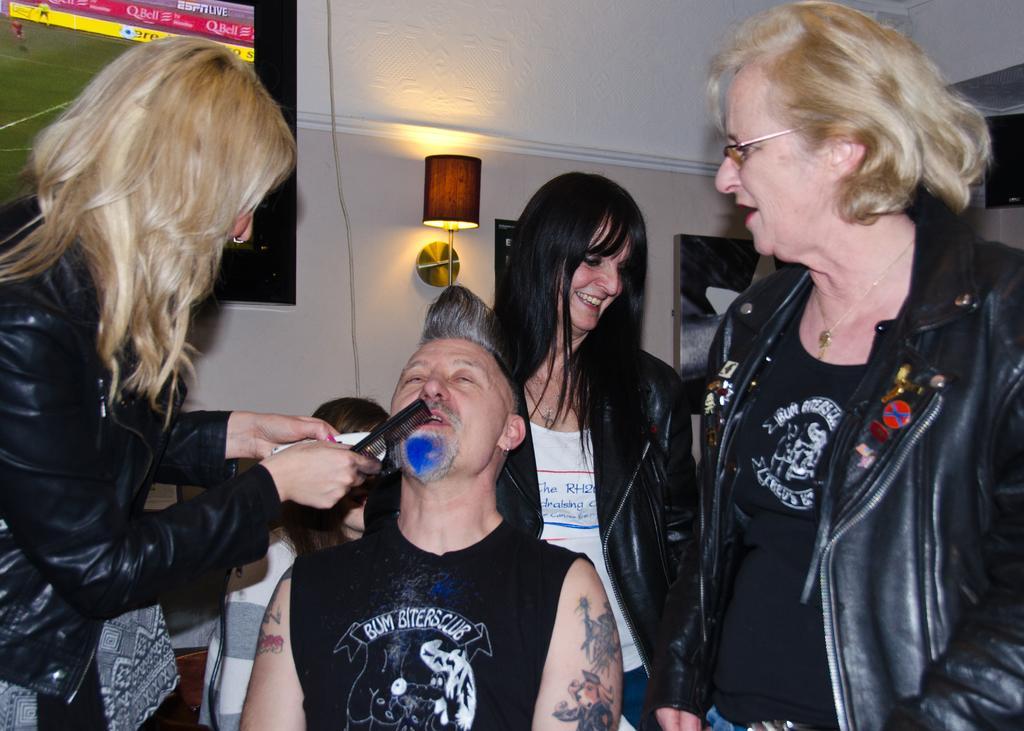Describe this image in one or two sentences. In this image I can see group of people. In front the person is sitting and wearing black color shirt and the person at left is wearing black color jacket and holding some object. Background I can see the screen attached to the wall and I can also see the light and the wall is in white color. 